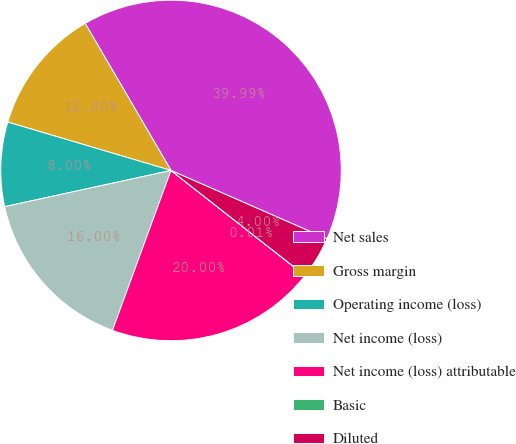Convert chart. <chart><loc_0><loc_0><loc_500><loc_500><pie_chart><fcel>Net sales<fcel>Gross margin<fcel>Operating income (loss)<fcel>Net income (loss)<fcel>Net income (loss) attributable<fcel>Basic<fcel>Diluted<nl><fcel>39.99%<fcel>12.0%<fcel>8.0%<fcel>16.0%<fcel>20.0%<fcel>0.01%<fcel>4.0%<nl></chart> 